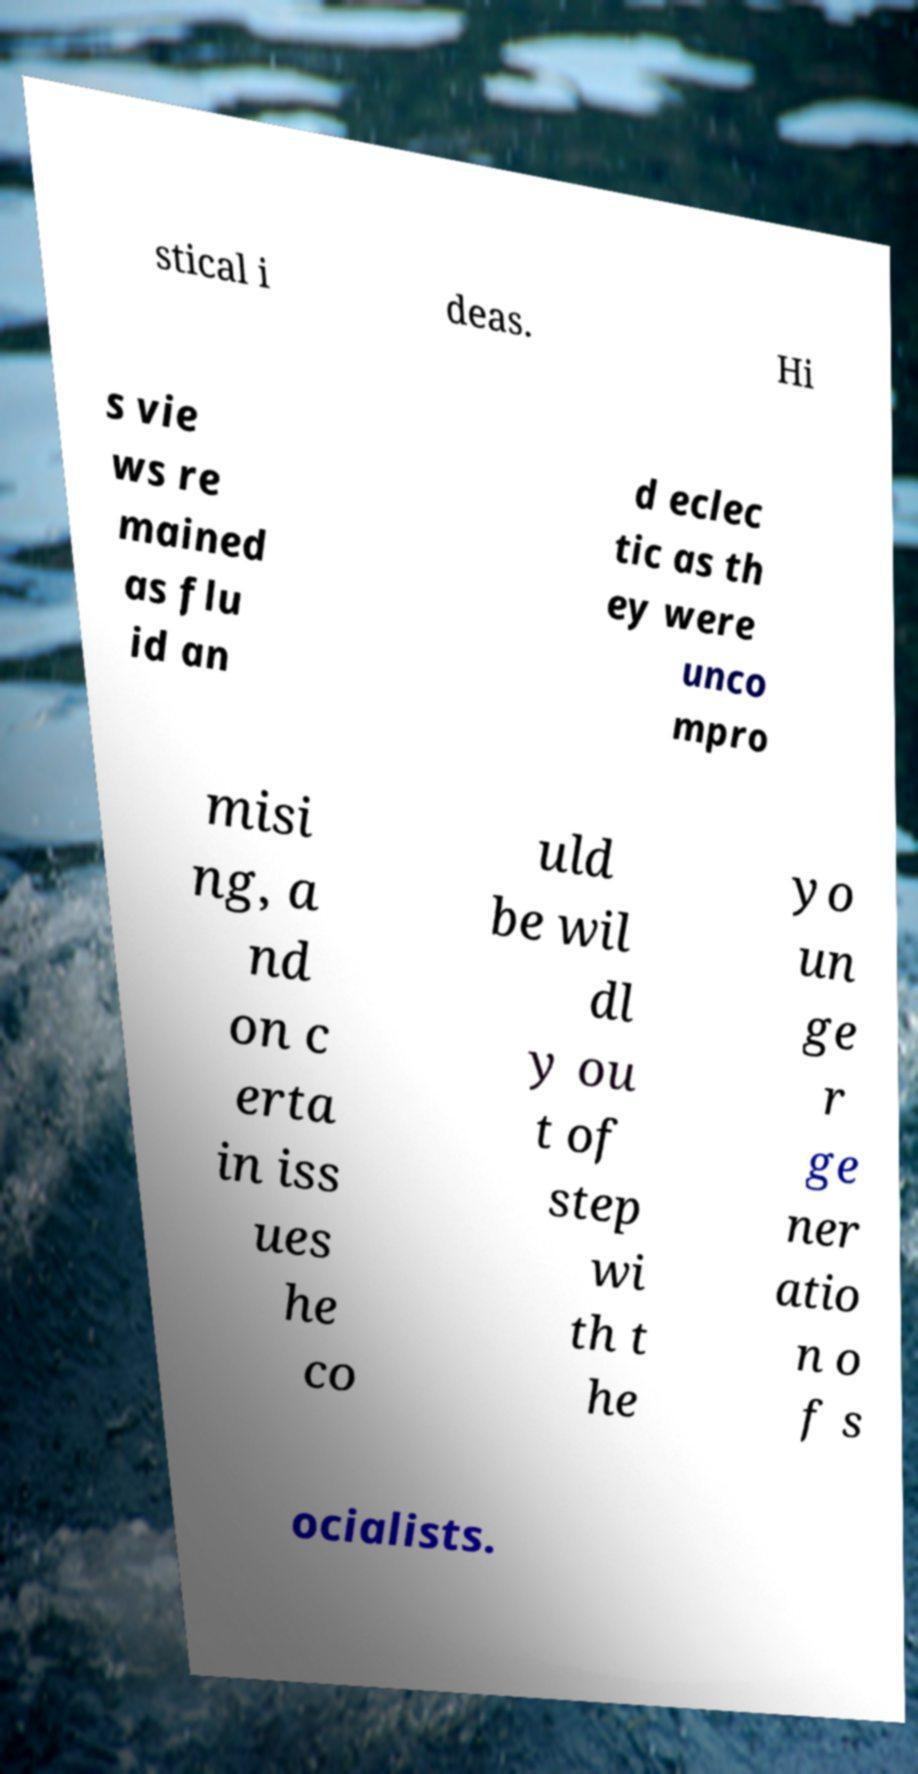I need the written content from this picture converted into text. Can you do that? stical i deas. Hi s vie ws re mained as flu id an d eclec tic as th ey were unco mpro misi ng, a nd on c erta in iss ues he co uld be wil dl y ou t of step wi th t he yo un ge r ge ner atio n o f s ocialists. 